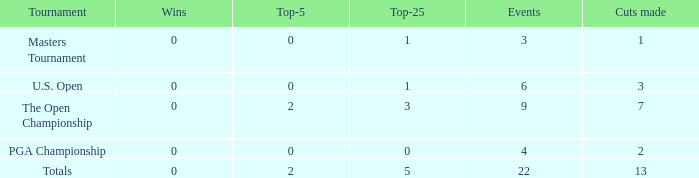How many total cuts were made in events with more than 0 wins and exactly 0 top-5s? 0.0. 